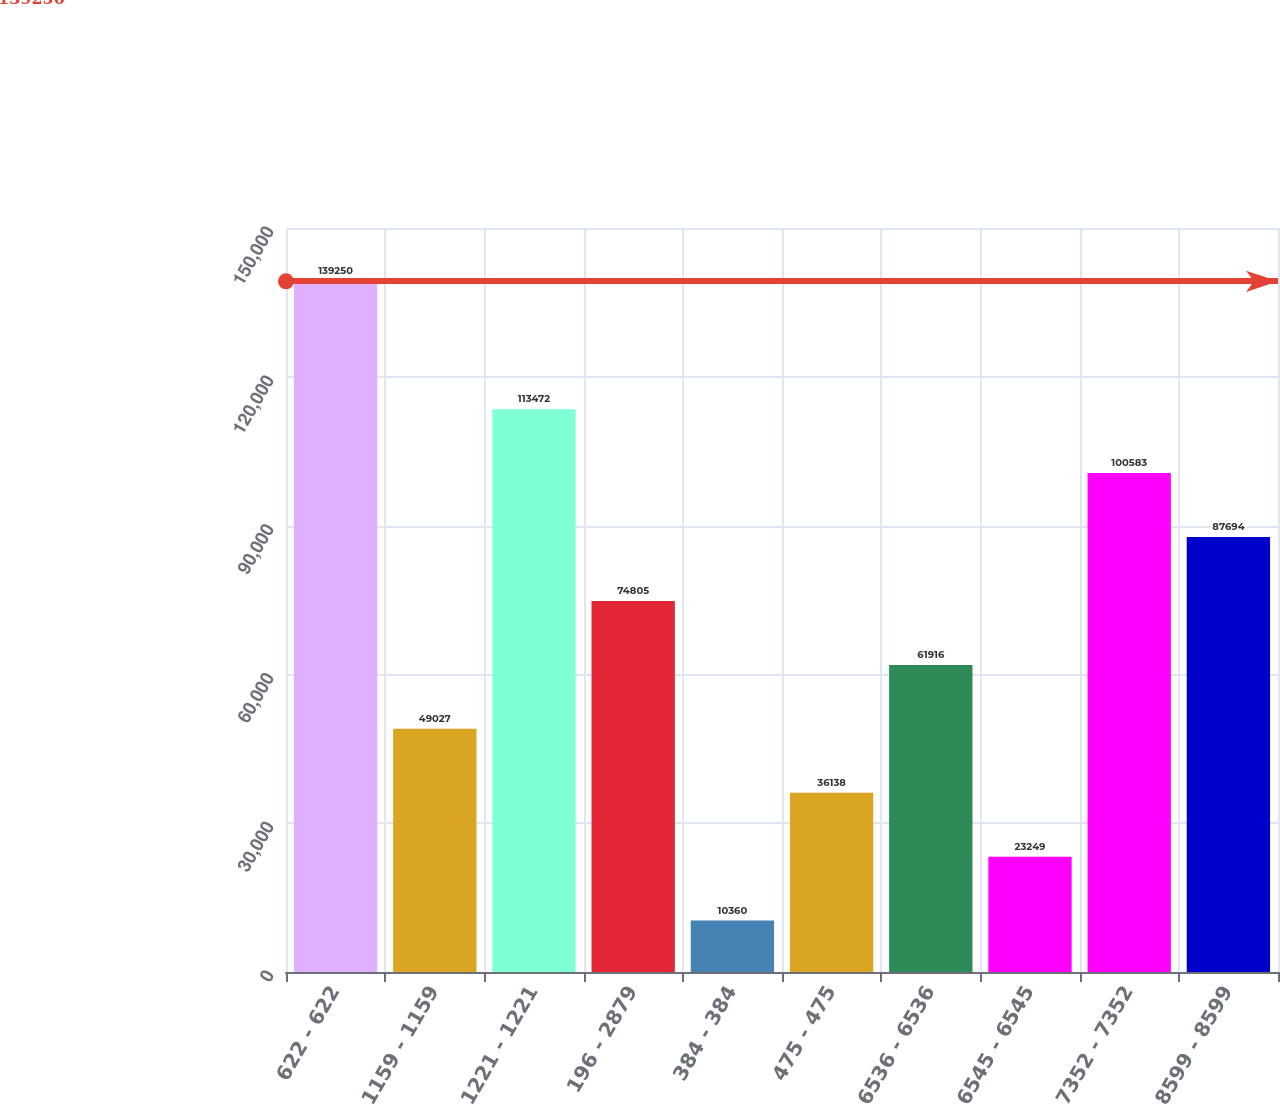<chart> <loc_0><loc_0><loc_500><loc_500><bar_chart><fcel>622 - 622<fcel>1159 - 1159<fcel>1221 - 1221<fcel>196 - 2879<fcel>384 - 384<fcel>475 - 475<fcel>6536 - 6536<fcel>6545 - 6545<fcel>7352 - 7352<fcel>8599 - 8599<nl><fcel>139250<fcel>49027<fcel>113472<fcel>74805<fcel>10360<fcel>36138<fcel>61916<fcel>23249<fcel>100583<fcel>87694<nl></chart> 